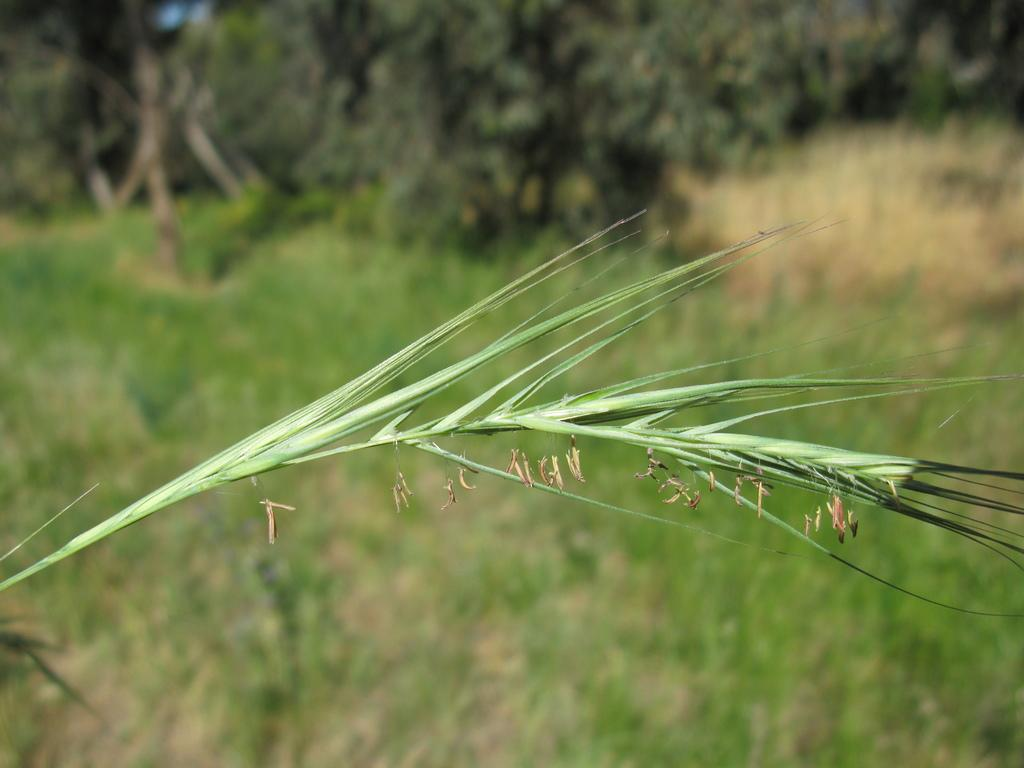What is located in the front of the image? There is a leaf in the front of the image. What can be seen in the background of the image? There are trees in the background of the image. What type of vegetation is on the ground in the image? There is grass on the ground in the image. What time of day is it in the image, and who is the judge in the scene? The image does not depict a specific time of day, and there is no judge present in the scene. 